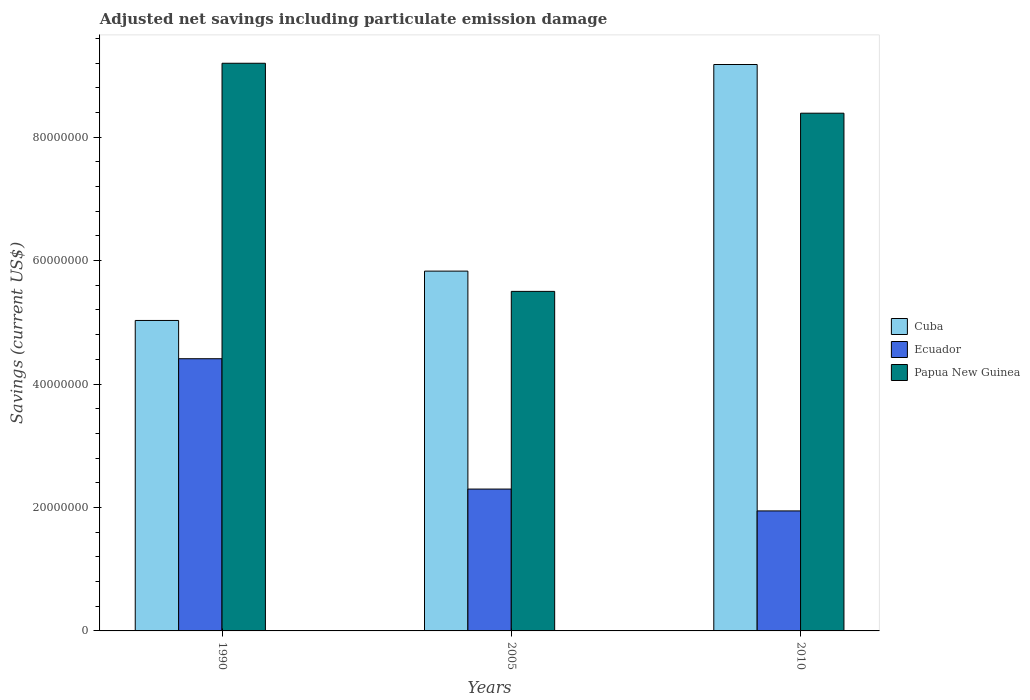How many groups of bars are there?
Keep it short and to the point. 3. How many bars are there on the 3rd tick from the left?
Your response must be concise. 3. How many bars are there on the 3rd tick from the right?
Ensure brevity in your answer.  3. What is the net savings in Cuba in 2005?
Provide a succinct answer. 5.83e+07. Across all years, what is the maximum net savings in Papua New Guinea?
Your answer should be compact. 9.20e+07. Across all years, what is the minimum net savings in Ecuador?
Offer a very short reply. 1.94e+07. In which year was the net savings in Ecuador maximum?
Offer a very short reply. 1990. What is the total net savings in Papua New Guinea in the graph?
Offer a terse response. 2.31e+08. What is the difference between the net savings in Papua New Guinea in 1990 and that in 2005?
Provide a short and direct response. 3.70e+07. What is the difference between the net savings in Cuba in 2010 and the net savings in Ecuador in 2005?
Provide a succinct answer. 6.88e+07. What is the average net savings in Ecuador per year?
Provide a succinct answer. 2.88e+07. In the year 2005, what is the difference between the net savings in Papua New Guinea and net savings in Cuba?
Your answer should be compact. -3.28e+06. In how many years, is the net savings in Papua New Guinea greater than 12000000 US$?
Make the answer very short. 3. What is the ratio of the net savings in Cuba in 1990 to that in 2005?
Your answer should be compact. 0.86. Is the net savings in Ecuador in 1990 less than that in 2005?
Offer a very short reply. No. What is the difference between the highest and the second highest net savings in Papua New Guinea?
Offer a very short reply. 8.09e+06. What is the difference between the highest and the lowest net savings in Papua New Guinea?
Keep it short and to the point. 3.70e+07. What does the 1st bar from the left in 1990 represents?
Offer a terse response. Cuba. What does the 3rd bar from the right in 2005 represents?
Your response must be concise. Cuba. How many years are there in the graph?
Make the answer very short. 3. Are the values on the major ticks of Y-axis written in scientific E-notation?
Your answer should be compact. No. Does the graph contain any zero values?
Keep it short and to the point. No. How are the legend labels stacked?
Provide a short and direct response. Vertical. What is the title of the graph?
Your response must be concise. Adjusted net savings including particulate emission damage. What is the label or title of the Y-axis?
Give a very brief answer. Savings (current US$). What is the Savings (current US$) in Cuba in 1990?
Ensure brevity in your answer.  5.03e+07. What is the Savings (current US$) of Ecuador in 1990?
Provide a succinct answer. 4.41e+07. What is the Savings (current US$) in Papua New Guinea in 1990?
Your answer should be compact. 9.20e+07. What is the Savings (current US$) of Cuba in 2005?
Make the answer very short. 5.83e+07. What is the Savings (current US$) of Ecuador in 2005?
Your answer should be very brief. 2.30e+07. What is the Savings (current US$) of Papua New Guinea in 2005?
Provide a succinct answer. 5.50e+07. What is the Savings (current US$) of Cuba in 2010?
Offer a very short reply. 9.18e+07. What is the Savings (current US$) of Ecuador in 2010?
Ensure brevity in your answer.  1.94e+07. What is the Savings (current US$) of Papua New Guinea in 2010?
Your answer should be very brief. 8.39e+07. Across all years, what is the maximum Savings (current US$) of Cuba?
Make the answer very short. 9.18e+07. Across all years, what is the maximum Savings (current US$) in Ecuador?
Offer a very short reply. 4.41e+07. Across all years, what is the maximum Savings (current US$) of Papua New Guinea?
Provide a short and direct response. 9.20e+07. Across all years, what is the minimum Savings (current US$) of Cuba?
Provide a succinct answer. 5.03e+07. Across all years, what is the minimum Savings (current US$) in Ecuador?
Keep it short and to the point. 1.94e+07. Across all years, what is the minimum Savings (current US$) in Papua New Guinea?
Your answer should be compact. 5.50e+07. What is the total Savings (current US$) in Cuba in the graph?
Keep it short and to the point. 2.00e+08. What is the total Savings (current US$) of Ecuador in the graph?
Your answer should be compact. 8.65e+07. What is the total Savings (current US$) in Papua New Guinea in the graph?
Offer a very short reply. 2.31e+08. What is the difference between the Savings (current US$) in Cuba in 1990 and that in 2005?
Make the answer very short. -7.99e+06. What is the difference between the Savings (current US$) in Ecuador in 1990 and that in 2005?
Your answer should be very brief. 2.11e+07. What is the difference between the Savings (current US$) of Papua New Guinea in 1990 and that in 2005?
Ensure brevity in your answer.  3.70e+07. What is the difference between the Savings (current US$) of Cuba in 1990 and that in 2010?
Give a very brief answer. -4.15e+07. What is the difference between the Savings (current US$) of Ecuador in 1990 and that in 2010?
Offer a very short reply. 2.47e+07. What is the difference between the Savings (current US$) of Papua New Guinea in 1990 and that in 2010?
Your answer should be compact. 8.09e+06. What is the difference between the Savings (current US$) of Cuba in 2005 and that in 2010?
Your answer should be compact. -3.35e+07. What is the difference between the Savings (current US$) of Ecuador in 2005 and that in 2010?
Ensure brevity in your answer.  3.54e+06. What is the difference between the Savings (current US$) in Papua New Guinea in 2005 and that in 2010?
Your response must be concise. -2.89e+07. What is the difference between the Savings (current US$) of Cuba in 1990 and the Savings (current US$) of Ecuador in 2005?
Offer a very short reply. 2.73e+07. What is the difference between the Savings (current US$) in Cuba in 1990 and the Savings (current US$) in Papua New Guinea in 2005?
Provide a succinct answer. -4.71e+06. What is the difference between the Savings (current US$) in Ecuador in 1990 and the Savings (current US$) in Papua New Guinea in 2005?
Provide a succinct answer. -1.09e+07. What is the difference between the Savings (current US$) in Cuba in 1990 and the Savings (current US$) in Ecuador in 2010?
Provide a short and direct response. 3.09e+07. What is the difference between the Savings (current US$) of Cuba in 1990 and the Savings (current US$) of Papua New Guinea in 2010?
Offer a terse response. -3.36e+07. What is the difference between the Savings (current US$) in Ecuador in 1990 and the Savings (current US$) in Papua New Guinea in 2010?
Ensure brevity in your answer.  -3.98e+07. What is the difference between the Savings (current US$) of Cuba in 2005 and the Savings (current US$) of Ecuador in 2010?
Provide a succinct answer. 3.89e+07. What is the difference between the Savings (current US$) in Cuba in 2005 and the Savings (current US$) in Papua New Guinea in 2010?
Offer a very short reply. -2.56e+07. What is the difference between the Savings (current US$) in Ecuador in 2005 and the Savings (current US$) in Papua New Guinea in 2010?
Your answer should be compact. -6.09e+07. What is the average Savings (current US$) of Cuba per year?
Provide a short and direct response. 6.68e+07. What is the average Savings (current US$) in Ecuador per year?
Give a very brief answer. 2.88e+07. What is the average Savings (current US$) in Papua New Guinea per year?
Make the answer very short. 7.70e+07. In the year 1990, what is the difference between the Savings (current US$) in Cuba and Savings (current US$) in Ecuador?
Your response must be concise. 6.20e+06. In the year 1990, what is the difference between the Savings (current US$) of Cuba and Savings (current US$) of Papua New Guinea?
Give a very brief answer. -4.17e+07. In the year 1990, what is the difference between the Savings (current US$) in Ecuador and Savings (current US$) in Papua New Guinea?
Offer a terse response. -4.79e+07. In the year 2005, what is the difference between the Savings (current US$) of Cuba and Savings (current US$) of Ecuador?
Your answer should be compact. 3.53e+07. In the year 2005, what is the difference between the Savings (current US$) in Cuba and Savings (current US$) in Papua New Guinea?
Ensure brevity in your answer.  3.28e+06. In the year 2005, what is the difference between the Savings (current US$) of Ecuador and Savings (current US$) of Papua New Guinea?
Make the answer very short. -3.20e+07. In the year 2010, what is the difference between the Savings (current US$) in Cuba and Savings (current US$) in Ecuador?
Provide a succinct answer. 7.23e+07. In the year 2010, what is the difference between the Savings (current US$) of Cuba and Savings (current US$) of Papua New Guinea?
Ensure brevity in your answer.  7.89e+06. In the year 2010, what is the difference between the Savings (current US$) in Ecuador and Savings (current US$) in Papua New Guinea?
Offer a terse response. -6.44e+07. What is the ratio of the Savings (current US$) of Cuba in 1990 to that in 2005?
Keep it short and to the point. 0.86. What is the ratio of the Savings (current US$) in Ecuador in 1990 to that in 2005?
Provide a short and direct response. 1.92. What is the ratio of the Savings (current US$) of Papua New Guinea in 1990 to that in 2005?
Make the answer very short. 1.67. What is the ratio of the Savings (current US$) of Cuba in 1990 to that in 2010?
Your answer should be compact. 0.55. What is the ratio of the Savings (current US$) in Ecuador in 1990 to that in 2010?
Offer a very short reply. 2.27. What is the ratio of the Savings (current US$) in Papua New Guinea in 1990 to that in 2010?
Provide a short and direct response. 1.1. What is the ratio of the Savings (current US$) in Cuba in 2005 to that in 2010?
Give a very brief answer. 0.64. What is the ratio of the Savings (current US$) of Ecuador in 2005 to that in 2010?
Offer a terse response. 1.18. What is the ratio of the Savings (current US$) in Papua New Guinea in 2005 to that in 2010?
Your answer should be very brief. 0.66. What is the difference between the highest and the second highest Savings (current US$) in Cuba?
Make the answer very short. 3.35e+07. What is the difference between the highest and the second highest Savings (current US$) of Ecuador?
Offer a terse response. 2.11e+07. What is the difference between the highest and the second highest Savings (current US$) in Papua New Guinea?
Provide a succinct answer. 8.09e+06. What is the difference between the highest and the lowest Savings (current US$) of Cuba?
Make the answer very short. 4.15e+07. What is the difference between the highest and the lowest Savings (current US$) of Ecuador?
Your answer should be compact. 2.47e+07. What is the difference between the highest and the lowest Savings (current US$) in Papua New Guinea?
Provide a succinct answer. 3.70e+07. 